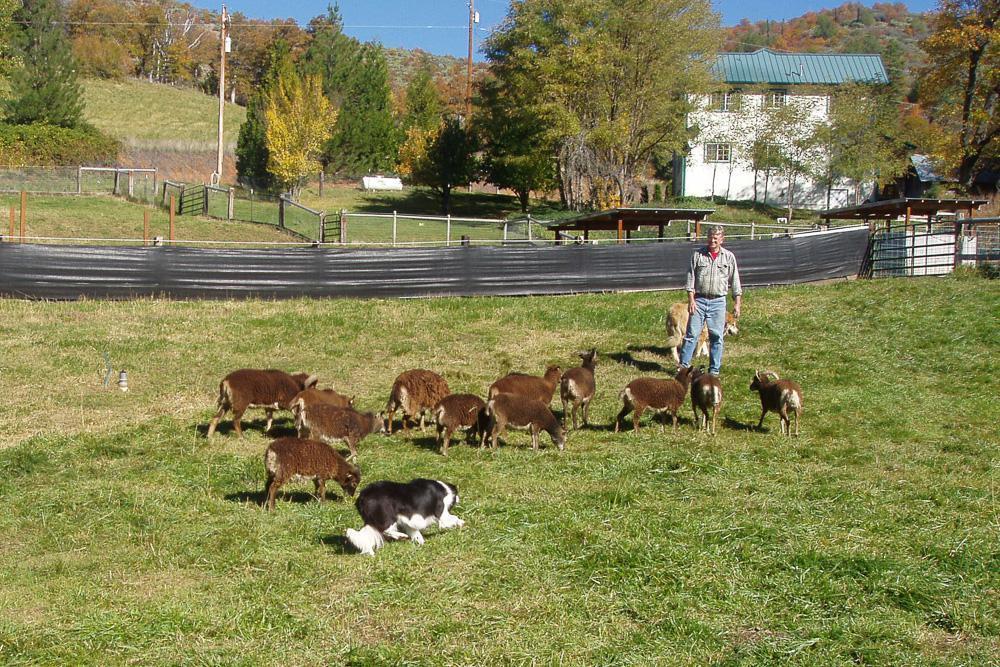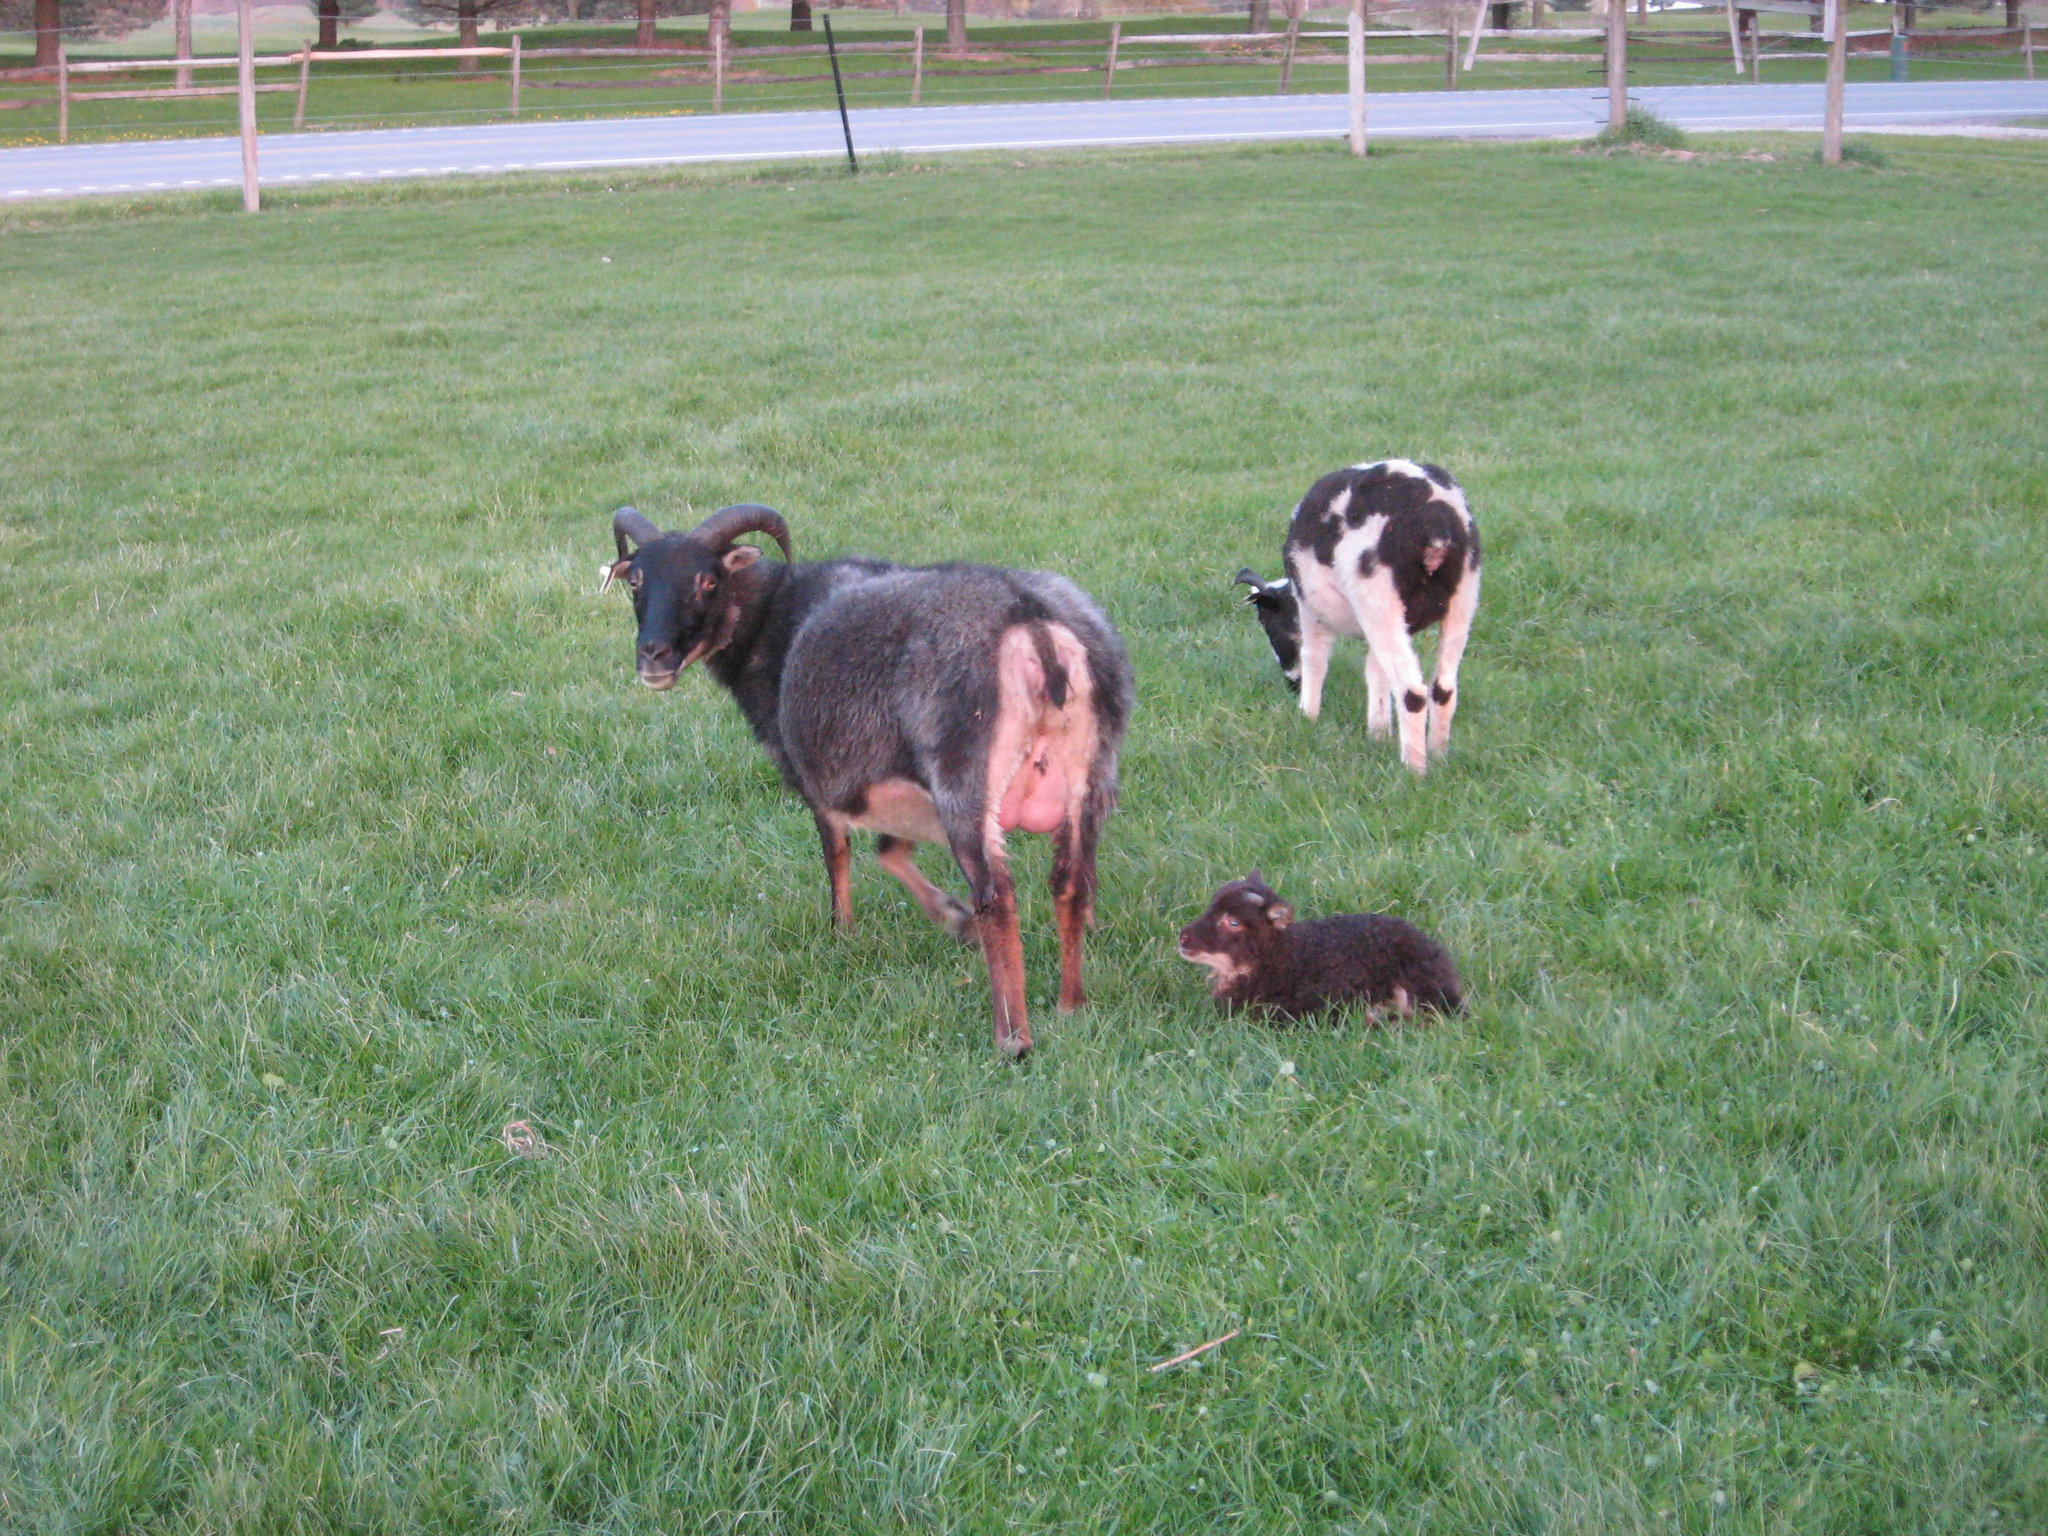The first image is the image on the left, the second image is the image on the right. For the images displayed, is the sentence "The human in one of the images is wearing a baseball cap." factually correct? Answer yes or no. No. 